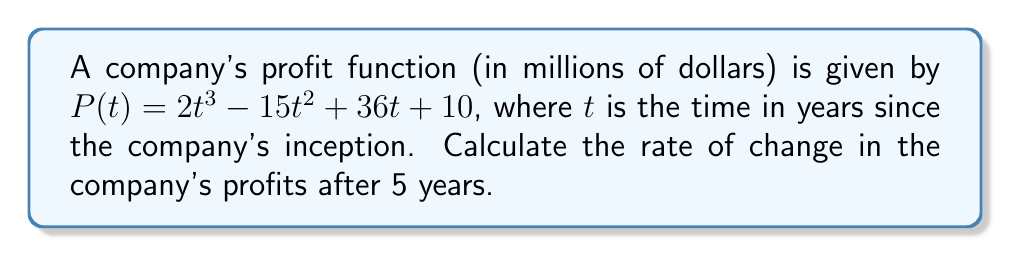Show me your answer to this math problem. To find the rate of change in the company's profits after 5 years, we need to calculate the derivative of the profit function $P(t)$ and evaluate it at $t=5$. Here's the step-by-step process:

1) The profit function is $P(t) = 2t^3 - 15t^2 + 36t + 10$

2) To find the rate of change, we need to calculate $P'(t)$:
   $P'(t) = \frac{d}{dt}[2t^3 - 15t^2 + 36t + 10]$

3) Using the power rule and constant rule of differentiation:
   $P'(t) = 6t^2 - 30t + 36$

4) Now, we need to evaluate $P'(5)$:
   $P'(5) = 6(5)^2 - 30(5) + 36$

5) Simplifying:
   $P'(5) = 6(25) - 150 + 36$
   $P'(5) = 150 - 150 + 36$
   $P'(5) = 36$

Therefore, after 5 years, the rate of change in the company's profits is 36 million dollars per year.
Answer: $36$ million dollars per year 